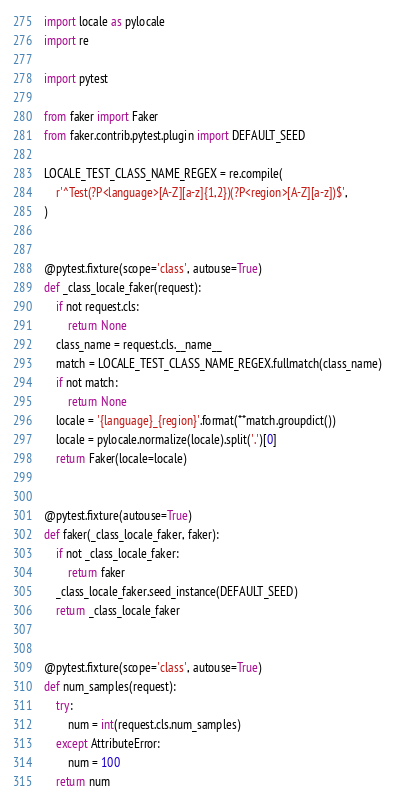<code> <loc_0><loc_0><loc_500><loc_500><_Python_>import locale as pylocale
import re

import pytest

from faker import Faker
from faker.contrib.pytest.plugin import DEFAULT_SEED

LOCALE_TEST_CLASS_NAME_REGEX = re.compile(
    r'^Test(?P<language>[A-Z][a-z]{1,2})(?P<region>[A-Z][a-z])$',
)


@pytest.fixture(scope='class', autouse=True)
def _class_locale_faker(request):
    if not request.cls:
        return None
    class_name = request.cls.__name__
    match = LOCALE_TEST_CLASS_NAME_REGEX.fullmatch(class_name)
    if not match:
        return None
    locale = '{language}_{region}'.format(**match.groupdict())
    locale = pylocale.normalize(locale).split('.')[0]
    return Faker(locale=locale)


@pytest.fixture(autouse=True)
def faker(_class_locale_faker, faker):
    if not _class_locale_faker:
        return faker
    _class_locale_faker.seed_instance(DEFAULT_SEED)
    return _class_locale_faker


@pytest.fixture(scope='class', autouse=True)
def num_samples(request):
    try:
        num = int(request.cls.num_samples)
    except AttributeError:
        num = 100
    return num
</code> 